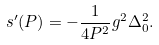Convert formula to latex. <formula><loc_0><loc_0><loc_500><loc_500>s ^ { \prime } ( P ) = - \frac { 1 } { 4 P ^ { 2 } } g ^ { 2 } \Delta _ { 0 } ^ { 2 } .</formula> 